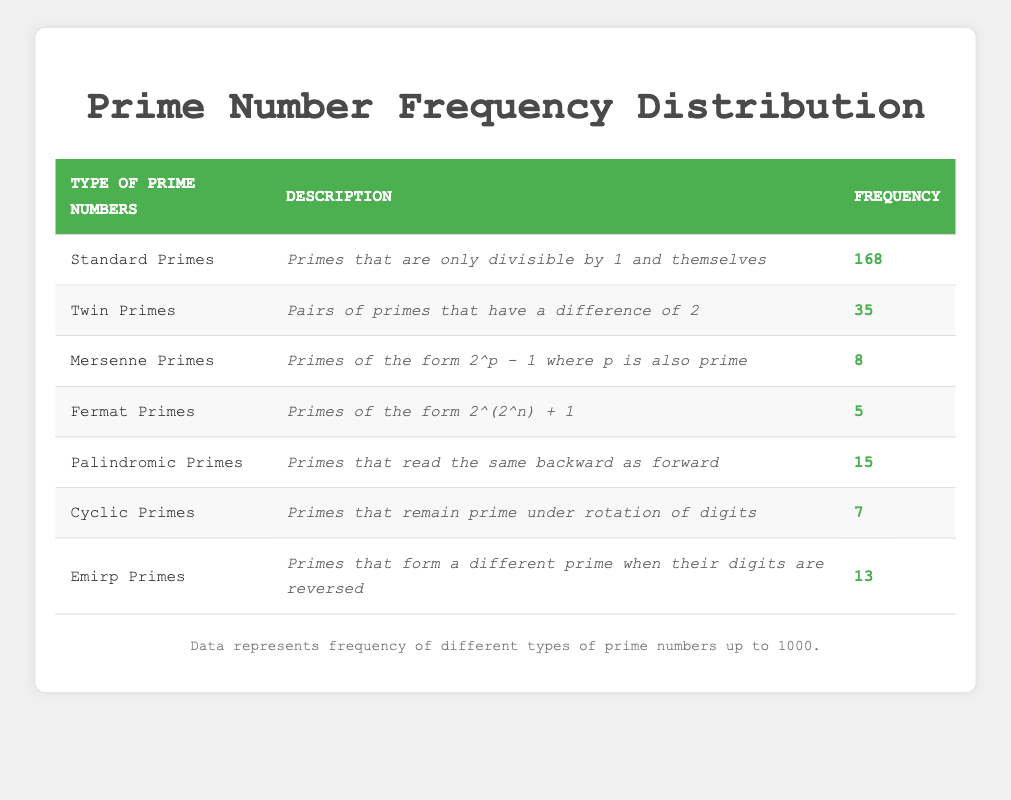What is the frequency of Standard Primes? The frequency for Standard Primes is stated directly in the table under the relevant column. It is listed as 168.
Answer: 168 How many types of primes are listed in the table? The table contains seven different types of primes as indicated by the seven rows in the frequency distribution.
Answer: 7 What is the combined frequency of Twin Primes and Emirp Primes? To find the combined frequency, add the frequencies of Twin Primes (35) and Emirp Primes (13): 35 + 13 = 48.
Answer: 48 Is there more frequency of Palindromic Primes than Fermat Primes? Comparing the frequencies, Palindromic Primes have a frequency of 15, while Fermat Primes have a frequency of 5. Since 15 is greater than 5, it is true.
Answer: Yes How many more Standard Primes are there than Mersenne Primes? To find the difference, subtract the frequency of Mersenne Primes (8) from the frequency of Standard Primes (168): 168 - 8 = 160.
Answer: 160 What is the frequency of Cyclic Primes? The frequency for Cyclic Primes is listed in the table under the relevant column, which shows it as 7.
Answer: 7 What percentage of the total primes are Mersenne Primes? First, sum the frequencies of all types of primes: 168 + 35 + 8 + 5 + 15 + 7 + 13 = 251. Then, calculate the percentage of Mersenne Primes: (8 / 251) * 100 = 3.18%.
Answer: Approximately 3.18% Are there more Twin Primes or Cyclic Primes? By comparing the frequencies, Twin Primes have a frequency of 35, and Cyclic Primes have a frequency of 7. Since 35 is greater than 7, it is true that there are more Twin Primes.
Answer: Yes What is the total frequency of all the given types of primes? To find the total frequency, all frequencies are summed: 168 + 35 + 8 + 5 + 15 + 7 + 13 = 251.
Answer: 251 